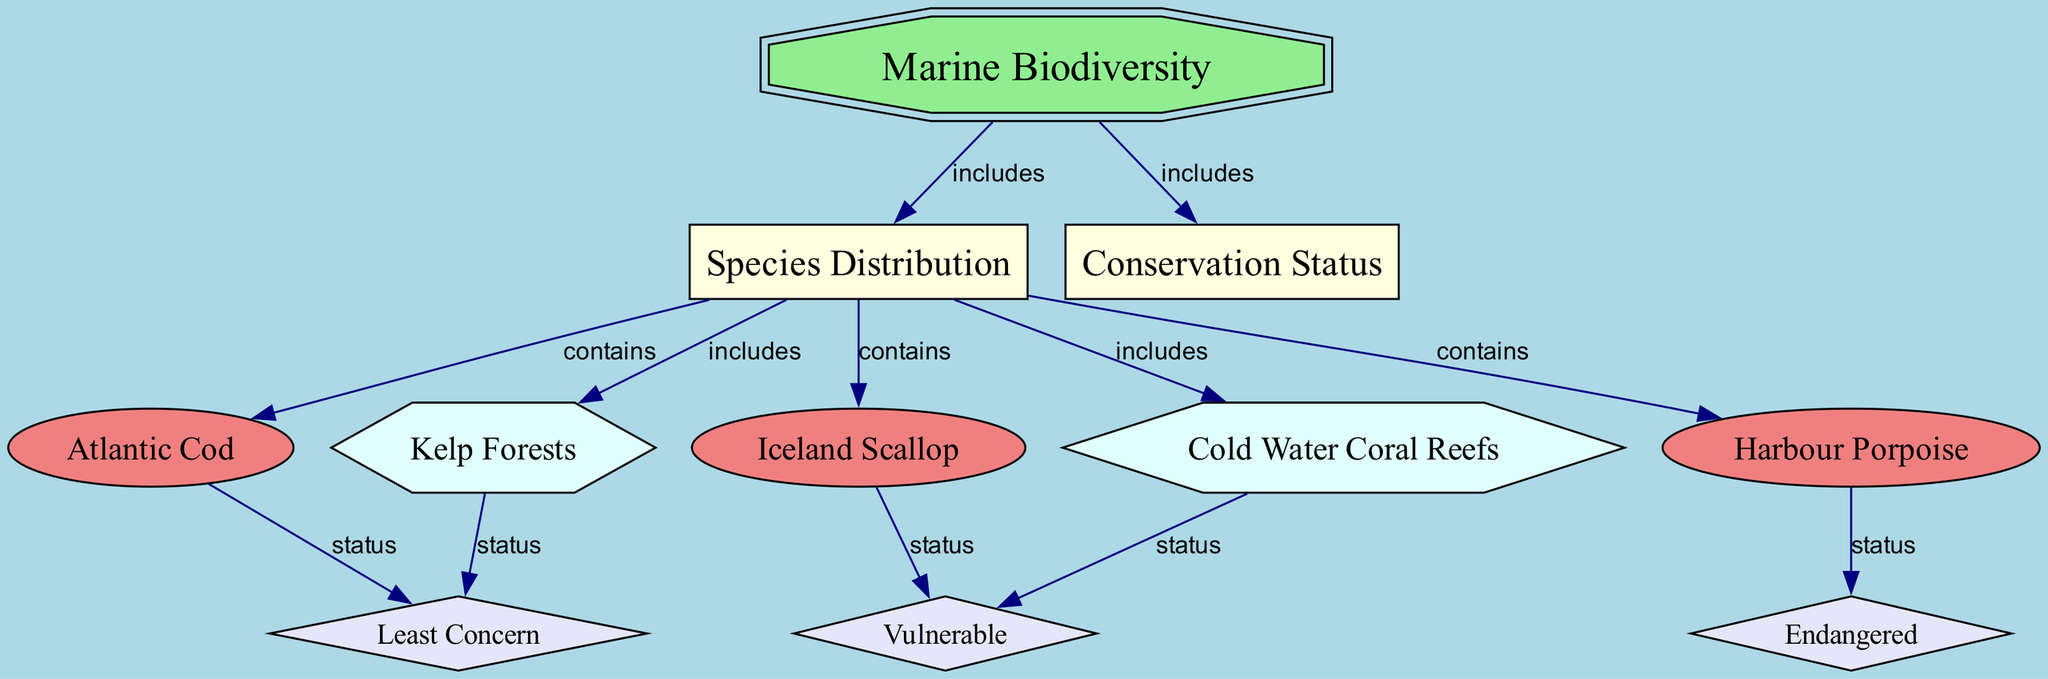What is the main topic of the diagram? The main topic of the diagram is indicated by the top-level node labeled "Marine Biodiversity". This is a single node representing the central focus of the diagram.
Answer: Marine Biodiversity How many species are listed in the diagram? Upon reviewing the diagram, it shows three distinct species nodes: Atlantic Cod, Iceland Scallop, and Harbour Porpoise. Counting these provides a total of three species.
Answer: 3 Which species is labeled as "Endangered"? The status of species can be traced through the relationships shown in the diagram. The node for Harbour Porpoise connects to the status labeled "Endangered". Hence, this species is at risk.
Answer: Harbour Porpoise What habitat is associated with both "Cold Water Coral Reefs" and "Iceland Scallop"? The flow from the subcategory "Species Distribution" includes connections to multiple habitats. However, Cold Water Coral Reefs connect primarily to the vulnerable status and are not directly linked to Iceland Scallop. Thus, there is no habitat that meets this criterion.
Answer: None Which species have a conservation status of "Least Concern"? In the diagram, the Atlantic Cod and Kelp Forests nodes both connect to the "Least Concern" status. By examining their relationships, it’s clear that they share this status.
Answer: Atlantic Cod, Kelp Forests How many conservation statuses are displayed in total? The diagram shows three distinct status labels: Endangered, Vulnerable, and Least Concern. Counting these gives a total of three statuses represented in the diagram.
Answer: 3 Which habitat is linked to a "Vulnerable" status and what species is affected? The node for Cold Water Coral Reefs links to a "Vulnerable" status. Additionally, the Iceland Scallop is also labeled as vulnerable, by examining both relationships in the diagram.
Answer: Cold Water Coral Reefs, Iceland Scallop What is the relationship between "Marine Biodiversity" and "Species Distribution"? The diagram indicates that "Marine Biodiversity" is directly related to "Species Distribution" by the edge labeled "includes". This means Species Distribution is a component of Marine Biodiversity.
Answer: includes Which species has the most severe conservation status? By reviewing the species' status nodes, Harbour Porpoise is designated as "Endangered”, making it the species with the most severe conservation status among those listed.
Answer: Harbour Porpoise 